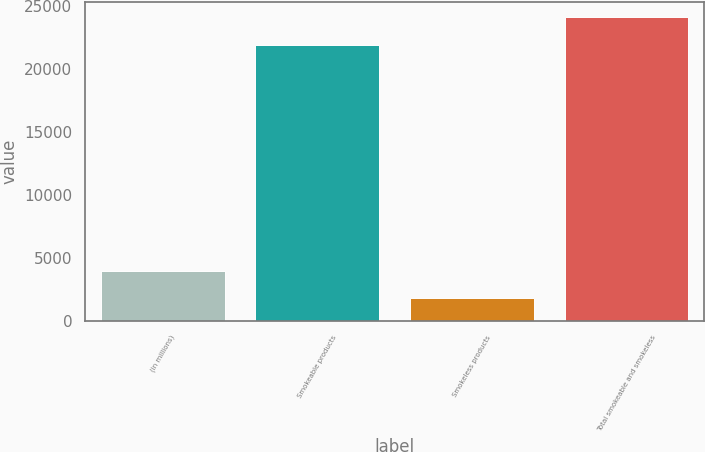Convert chart. <chart><loc_0><loc_0><loc_500><loc_500><bar_chart><fcel>(in millions)<fcel>Smokeable products<fcel>Smokeless products<fcel>Total smokeable and smokeless<nl><fcel>4002.9<fcel>21939<fcel>1809<fcel>24132.9<nl></chart> 